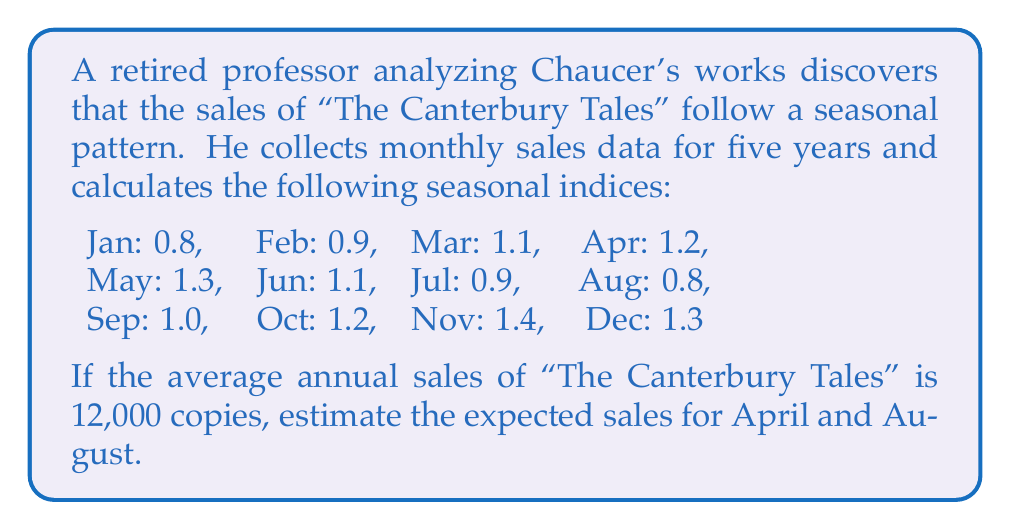Can you answer this question? To solve this problem, we need to understand the concept of seasonal indices and how they relate to average sales. Let's break it down step-by-step:

1. Seasonal indices represent the relative strength of sales in each month compared to the average month. An index of 1.0 means the month has average sales, while values above 1.0 indicate higher-than-average sales, and values below 1.0 indicate lower-than-average sales.

2. The average annual sales is given as 12,000 copies. To find the average monthly sales, we divide this by 12:

   $$\text{Average monthly sales} = \frac{12,000}{12} = 1,000 \text{ copies}$$

3. To estimate the sales for a specific month, we multiply the average monthly sales by the seasonal index for that month:

   $$\text{Estimated monthly sales} = \text{Average monthly sales} \times \text{Seasonal index}$$

4. For April:
   Seasonal index = 1.2
   $$\text{Estimated April sales} = 1,000 \times 1.2 = 1,200 \text{ copies}$$

5. For August:
   Seasonal index = 0.8
   $$\text{Estimated August sales} = 1,000 \times 0.8 = 800 \text{ copies}$$

This analysis shows that sales of "The Canterbury Tales" are expected to be higher in April (20% above average) and lower in August (20% below average), reflecting the seasonal pattern in the book's popularity.
Answer: The expected sales for April are 1,200 copies, and for August are 800 copies. 